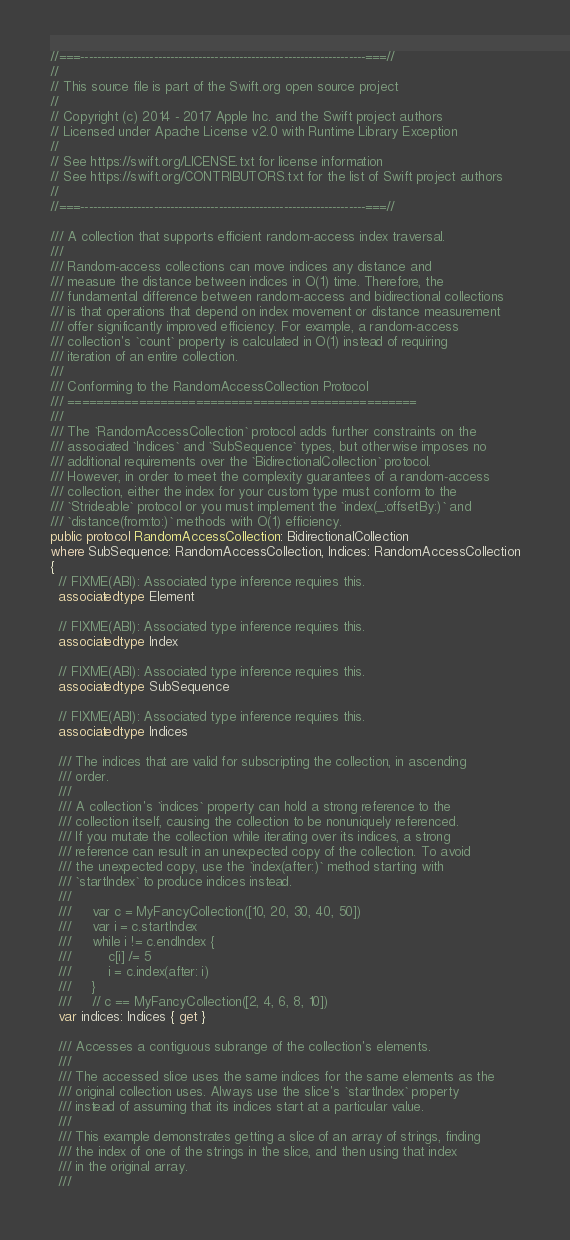<code> <loc_0><loc_0><loc_500><loc_500><_Swift_>//===----------------------------------------------------------------------===//
//
// This source file is part of the Swift.org open source project
//
// Copyright (c) 2014 - 2017 Apple Inc. and the Swift project authors
// Licensed under Apache License v2.0 with Runtime Library Exception
//
// See https://swift.org/LICENSE.txt for license information
// See https://swift.org/CONTRIBUTORS.txt for the list of Swift project authors
//
//===----------------------------------------------------------------------===//

/// A collection that supports efficient random-access index traversal.
///
/// Random-access collections can move indices any distance and 
/// measure the distance between indices in O(1) time. Therefore, the
/// fundamental difference between random-access and bidirectional collections
/// is that operations that depend on index movement or distance measurement
/// offer significantly improved efficiency. For example, a random-access
/// collection's `count` property is calculated in O(1) instead of requiring
/// iteration of an entire collection.
///
/// Conforming to the RandomAccessCollection Protocol
/// =================================================
///
/// The `RandomAccessCollection` protocol adds further constraints on the
/// associated `Indices` and `SubSequence` types, but otherwise imposes no
/// additional requirements over the `BidirectionalCollection` protocol.
/// However, in order to meet the complexity guarantees of a random-access
/// collection, either the index for your custom type must conform to the
/// `Strideable` protocol or you must implement the `index(_:offsetBy:)` and
/// `distance(from:to:)` methods with O(1) efficiency.
public protocol RandomAccessCollection: BidirectionalCollection
where SubSequence: RandomAccessCollection, Indices: RandomAccessCollection
{
  // FIXME(ABI): Associated type inference requires this.
  associatedtype Element

  // FIXME(ABI): Associated type inference requires this.
  associatedtype Index

  // FIXME(ABI): Associated type inference requires this.
  associatedtype SubSequence

  // FIXME(ABI): Associated type inference requires this.
  associatedtype Indices

  /// The indices that are valid for subscripting the collection, in ascending
  /// order.
  ///
  /// A collection's `indices` property can hold a strong reference to the
  /// collection itself, causing the collection to be nonuniquely referenced.
  /// If you mutate the collection while iterating over its indices, a strong
  /// reference can result in an unexpected copy of the collection. To avoid
  /// the unexpected copy, use the `index(after:)` method starting with
  /// `startIndex` to produce indices instead.
  ///
  ///     var c = MyFancyCollection([10, 20, 30, 40, 50])
  ///     var i = c.startIndex
  ///     while i != c.endIndex {
  ///         c[i] /= 5
  ///         i = c.index(after: i)
  ///     }
  ///     // c == MyFancyCollection([2, 4, 6, 8, 10])
  var indices: Indices { get }

  /// Accesses a contiguous subrange of the collection's elements.
  ///
  /// The accessed slice uses the same indices for the same elements as the
  /// original collection uses. Always use the slice's `startIndex` property
  /// instead of assuming that its indices start at a particular value.
  ///
  /// This example demonstrates getting a slice of an array of strings, finding
  /// the index of one of the strings in the slice, and then using that index
  /// in the original array.
  ///</code> 